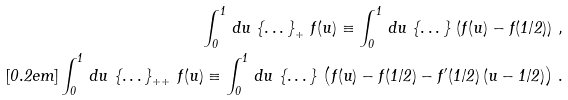<formula> <loc_0><loc_0><loc_500><loc_500>\int _ { 0 } ^ { 1 } \, d u \, \left \{ \dots \right \} _ { + } \, f ( u ) \equiv \int _ { 0 } ^ { 1 } \, d u \, \left \{ \dots \right \} \, \left ( f ( u ) - f ( 1 / 2 ) \right ) \, , \\ [ 0 . 2 e m ] \int _ { 0 } ^ { 1 } \, d u \, \left \{ \dots \right \} _ { + + } \, f ( u ) \equiv \int _ { 0 } ^ { 1 } \, d u \, \left \{ \dots \right \} \, \left ( f ( u ) - f ( 1 / 2 ) - f ^ { \prime } ( 1 / 2 ) \, ( u - 1 / 2 ) \right ) \, .</formula> 